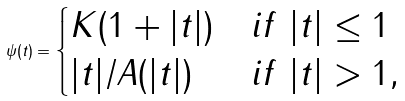<formula> <loc_0><loc_0><loc_500><loc_500>\psi ( t ) = \begin{cases} K ( 1 + | t | ) & i f \ | t | \leq 1 \\ | t | / A ( | t | ) & i f \ | t | > 1 , \end{cases}</formula> 